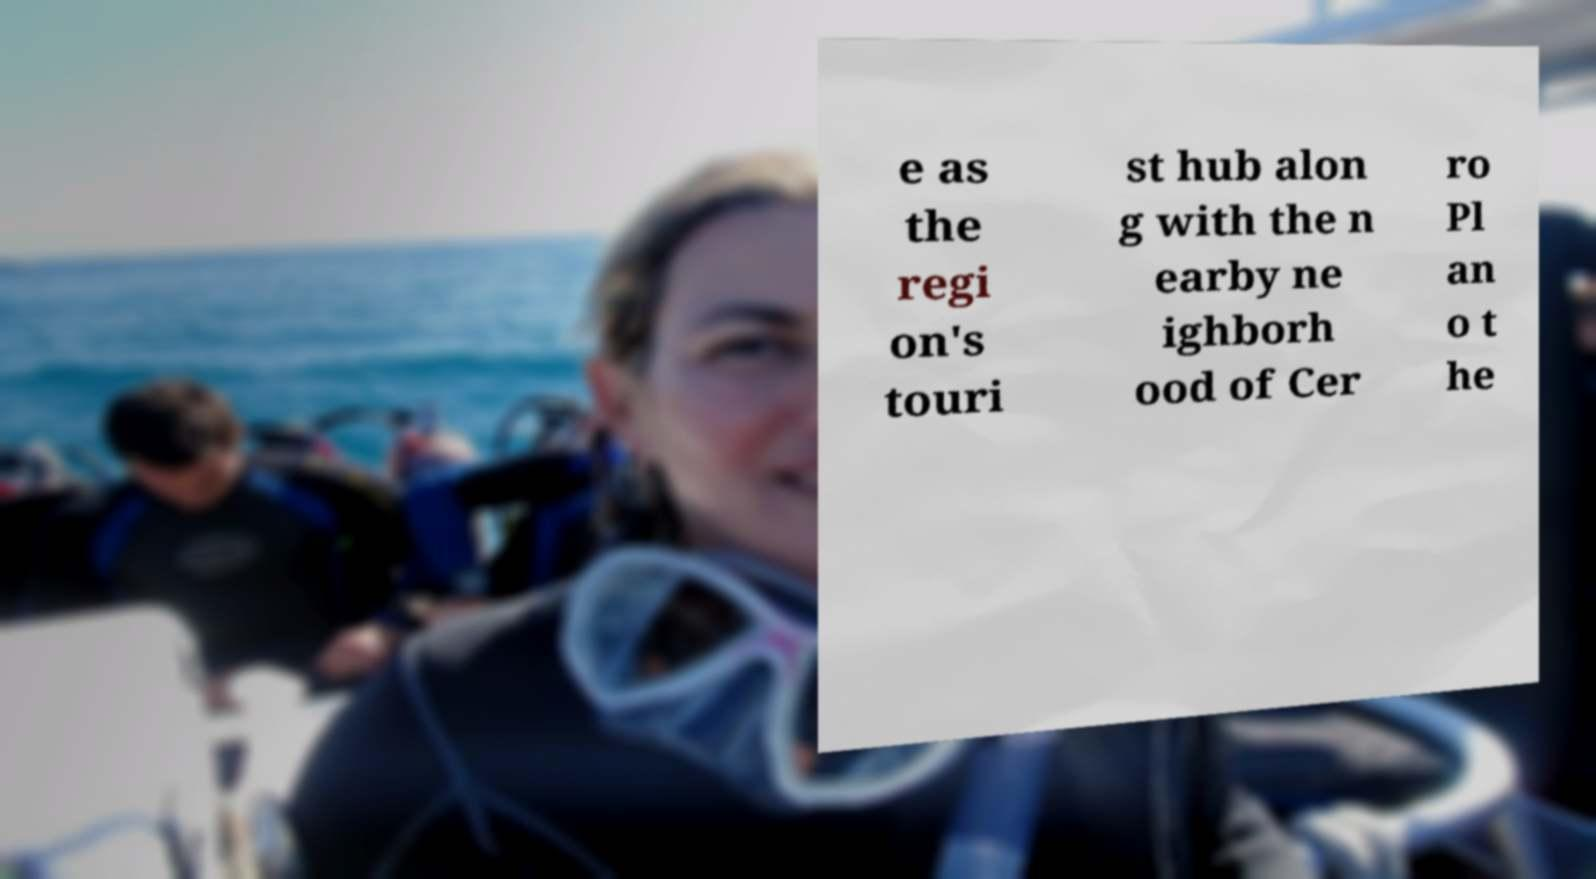I need the written content from this picture converted into text. Can you do that? e as the regi on's touri st hub alon g with the n earby ne ighborh ood of Cer ro Pl an o t he 